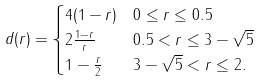Convert formula to latex. <formula><loc_0><loc_0><loc_500><loc_500>d ( r ) = & \begin{cases} 4 ( 1 - r ) & 0 \leq r \leq 0 . 5 \\ 2 \frac { 1 - r } { r } & 0 . 5 < r \leq 3 - \sqrt { 5 } \\ 1 - \frac { r } { 2 } & 3 - \sqrt { 5 } < r \leq 2 . \end{cases}</formula> 